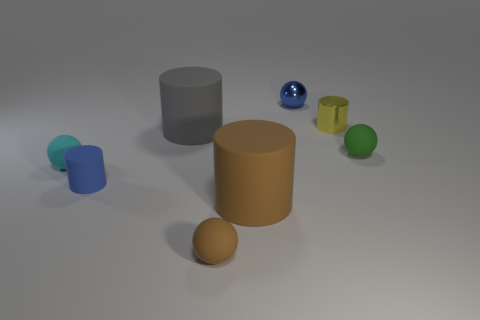Subtract 1 cylinders. How many cylinders are left? 3 Add 1 metal spheres. How many objects exist? 9 Add 6 small red shiny things. How many small red shiny things exist? 6 Subtract 0 purple blocks. How many objects are left? 8 Subtract all yellow rubber cylinders. Subtract all cyan spheres. How many objects are left? 7 Add 4 green rubber things. How many green rubber things are left? 5 